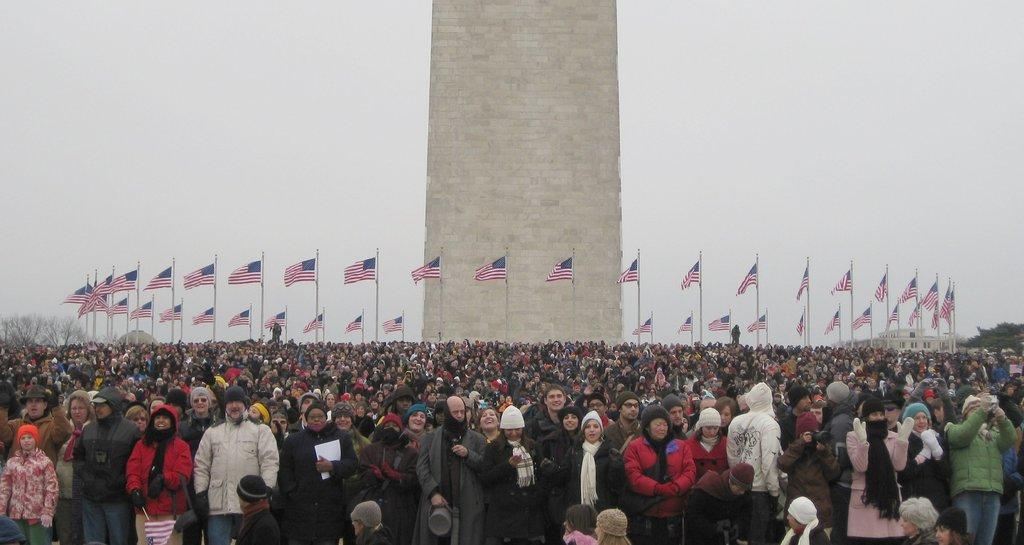What is located at the bottom of the image? There is a crowd at the bottom of the image. What can be seen in the image besides the crowd? There are flags visible in the image, as well as a tower in the center. What is visible in the background of the image? There are trees, at least one building, and the sky visible in the background of the image. What is the chance of finding a downtown jail in the image? There is no mention of a downtown jail in the image, so it cannot be determined if there is a chance of finding one. 